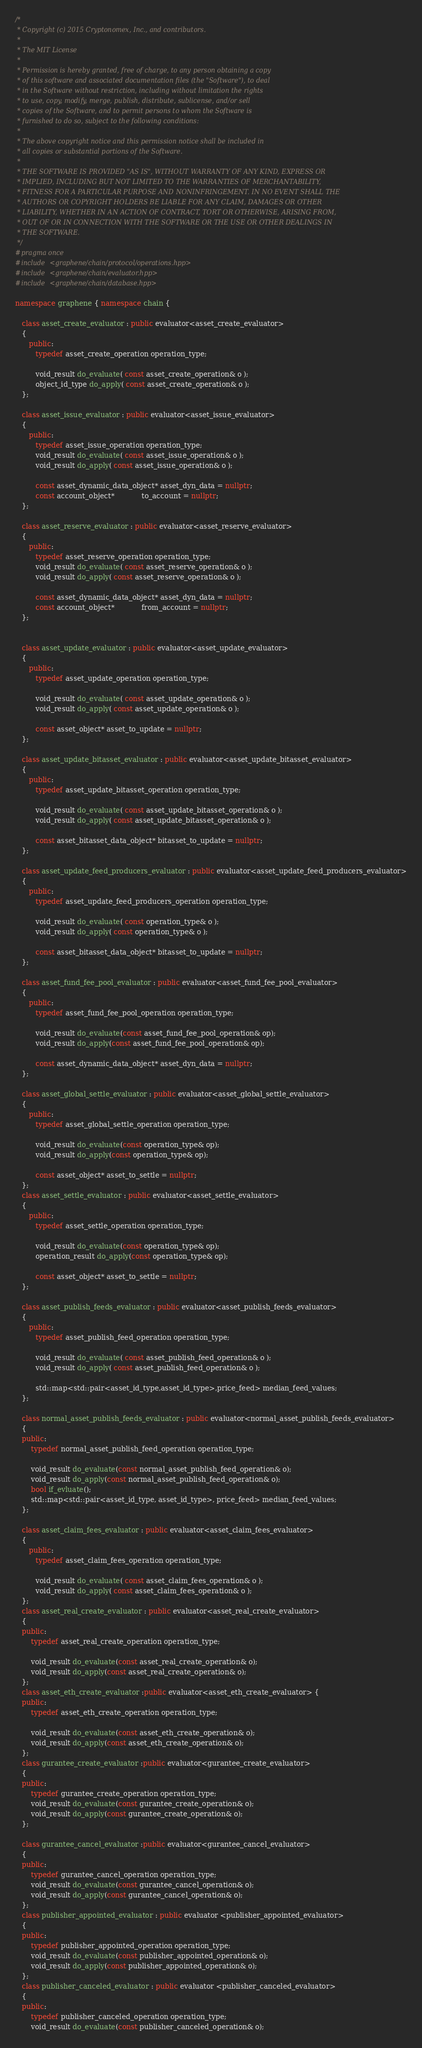Convert code to text. <code><loc_0><loc_0><loc_500><loc_500><_C++_>/*
 * Copyright (c) 2015 Cryptonomex, Inc., and contributors.
 *
 * The MIT License
 *
 * Permission is hereby granted, free of charge, to any person obtaining a copy
 * of this software and associated documentation files (the "Software"), to deal
 * in the Software without restriction, including without limitation the rights
 * to use, copy, modify, merge, publish, distribute, sublicense, and/or sell
 * copies of the Software, and to permit persons to whom the Software is
 * furnished to do so, subject to the following conditions:
 *
 * The above copyright notice and this permission notice shall be included in
 * all copies or substantial portions of the Software.
 *
 * THE SOFTWARE IS PROVIDED "AS IS", WITHOUT WARRANTY OF ANY KIND, EXPRESS OR
 * IMPLIED, INCLUDING BUT NOT LIMITED TO THE WARRANTIES OF MERCHANTABILITY,
 * FITNESS FOR A PARTICULAR PURPOSE AND NONINFRINGEMENT. IN NO EVENT SHALL THE
 * AUTHORS OR COPYRIGHT HOLDERS BE LIABLE FOR ANY CLAIM, DAMAGES OR OTHER
 * LIABILITY, WHETHER IN AN ACTION OF CONTRACT, TORT OR OTHERWISE, ARISING FROM,
 * OUT OF OR IN CONNECTION WITH THE SOFTWARE OR THE USE OR OTHER DEALINGS IN
 * THE SOFTWARE.
 */
#pragma once
#include <graphene/chain/protocol/operations.hpp>
#include <graphene/chain/evaluator.hpp>
#include <graphene/chain/database.hpp>

namespace graphene { namespace chain {

   class asset_create_evaluator : public evaluator<asset_create_evaluator>
   {
      public:
         typedef asset_create_operation operation_type;

         void_result do_evaluate( const asset_create_operation& o );
         object_id_type do_apply( const asset_create_operation& o );
   };

   class asset_issue_evaluator : public evaluator<asset_issue_evaluator>
   {
      public:
         typedef asset_issue_operation operation_type;
         void_result do_evaluate( const asset_issue_operation& o );
         void_result do_apply( const asset_issue_operation& o );

         const asset_dynamic_data_object* asset_dyn_data = nullptr;
         const account_object*            to_account = nullptr;
   };

   class asset_reserve_evaluator : public evaluator<asset_reserve_evaluator>
   {
      public:
         typedef asset_reserve_operation operation_type;
         void_result do_evaluate( const asset_reserve_operation& o );
         void_result do_apply( const asset_reserve_operation& o );

         const asset_dynamic_data_object* asset_dyn_data = nullptr;
         const account_object*            from_account = nullptr;
   };


   class asset_update_evaluator : public evaluator<asset_update_evaluator>
   {
      public:
         typedef asset_update_operation operation_type;

         void_result do_evaluate( const asset_update_operation& o );
         void_result do_apply( const asset_update_operation& o );

         const asset_object* asset_to_update = nullptr;
   };

   class asset_update_bitasset_evaluator : public evaluator<asset_update_bitasset_evaluator>
   {
      public:
         typedef asset_update_bitasset_operation operation_type;

         void_result do_evaluate( const asset_update_bitasset_operation& o );
         void_result do_apply( const asset_update_bitasset_operation& o );

         const asset_bitasset_data_object* bitasset_to_update = nullptr;
   };

   class asset_update_feed_producers_evaluator : public evaluator<asset_update_feed_producers_evaluator>
   {
      public:
         typedef asset_update_feed_producers_operation operation_type;

         void_result do_evaluate( const operation_type& o );
         void_result do_apply( const operation_type& o );

         const asset_bitasset_data_object* bitasset_to_update = nullptr;
   };

   class asset_fund_fee_pool_evaluator : public evaluator<asset_fund_fee_pool_evaluator>
   {
      public:
         typedef asset_fund_fee_pool_operation operation_type;

         void_result do_evaluate(const asset_fund_fee_pool_operation& op);
         void_result do_apply(const asset_fund_fee_pool_operation& op);

         const asset_dynamic_data_object* asset_dyn_data = nullptr;
   };

   class asset_global_settle_evaluator : public evaluator<asset_global_settle_evaluator>
   {
      public:
         typedef asset_global_settle_operation operation_type;

         void_result do_evaluate(const operation_type& op);
         void_result do_apply(const operation_type& op);

         const asset_object* asset_to_settle = nullptr;
   };
   class asset_settle_evaluator : public evaluator<asset_settle_evaluator>
   {
      public:
         typedef asset_settle_operation operation_type;

         void_result do_evaluate(const operation_type& op);
         operation_result do_apply(const operation_type& op);

         const asset_object* asset_to_settle = nullptr;
   };

   class asset_publish_feeds_evaluator : public evaluator<asset_publish_feeds_evaluator>
   {
      public:
         typedef asset_publish_feed_operation operation_type;

         void_result do_evaluate( const asset_publish_feed_operation& o );
         void_result do_apply( const asset_publish_feed_operation& o );

         std::map<std::pair<asset_id_type,asset_id_type>,price_feed> median_feed_values;
   };

   class normal_asset_publish_feeds_evaluator : public evaluator<normal_asset_publish_feeds_evaluator>
   {
   public:
	   typedef normal_asset_publish_feed_operation operation_type;

	   void_result do_evaluate(const normal_asset_publish_feed_operation& o);
	   void_result do_apply(const normal_asset_publish_feed_operation& o);
	   bool if_evluate();
	   std::map<std::pair<asset_id_type, asset_id_type>, price_feed> median_feed_values;
   };

   class asset_claim_fees_evaluator : public evaluator<asset_claim_fees_evaluator>
   {
      public:
         typedef asset_claim_fees_operation operation_type;

         void_result do_evaluate( const asset_claim_fees_operation& o );
         void_result do_apply( const asset_claim_fees_operation& o );
   };
   class asset_real_create_evaluator : public evaluator<asset_real_create_evaluator>
   {
   public:
	   typedef asset_real_create_operation operation_type;

	   void_result do_evaluate(const asset_real_create_operation& o);
	   void_result do_apply(const asset_real_create_operation& o);
   };
   class asset_eth_create_evaluator :public evaluator<asset_eth_create_evaluator> {
   public:
	   typedef asset_eth_create_operation operation_type;

	   void_result do_evaluate(const asset_eth_create_operation& o);
	   void_result do_apply(const asset_eth_create_operation& o);
   };
   class gurantee_create_evaluator :public evaluator<gurantee_create_evaluator>
   {
   public:
	   typedef gurantee_create_operation operation_type;
	   void_result do_evaluate(const gurantee_create_operation& o);
	   void_result do_apply(const gurantee_create_operation& o);
   };

   class gurantee_cancel_evaluator :public evaluator<gurantee_cancel_evaluator>
   {
   public:
	   typedef gurantee_cancel_operation operation_type;
	   void_result do_evaluate(const gurantee_cancel_operation& o);
	   void_result do_apply(const gurantee_cancel_operation& o);
   };
   class publisher_appointed_evaluator : public evaluator <publisher_appointed_evaluator>
   {
   public:
	   typedef publisher_appointed_operation operation_type;
	   void_result do_evaluate(const publisher_appointed_operation& o);
	   void_result do_apply(const publisher_appointed_operation& o);
   };
   class publisher_canceled_evaluator : public evaluator <publisher_canceled_evaluator>
   {
   public:
	   typedef publisher_canceled_operation operation_type;
	   void_result do_evaluate(const publisher_canceled_operation& o);</code> 